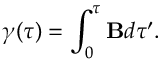Convert formula to latex. <formula><loc_0><loc_0><loc_500><loc_500>\gamma ( \tau ) = \int _ { 0 } ^ { \tau } B d \tau ^ { \prime } .</formula> 